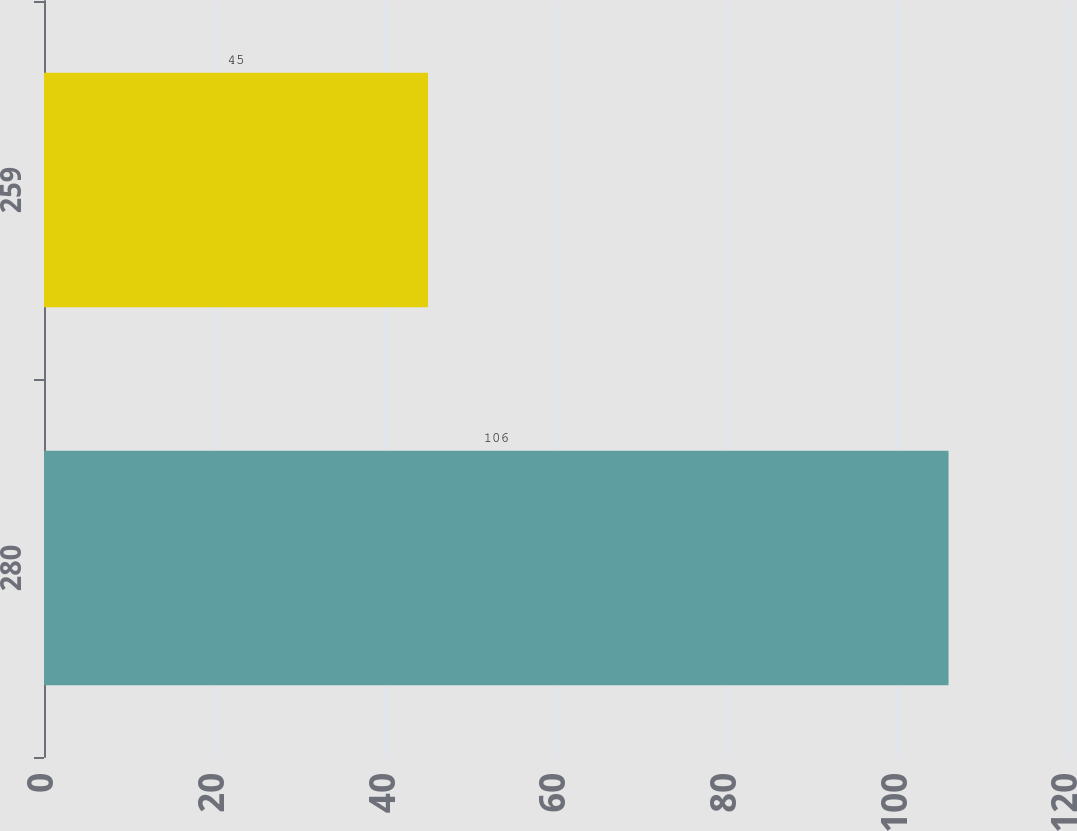Convert chart to OTSL. <chart><loc_0><loc_0><loc_500><loc_500><bar_chart><fcel>280<fcel>259<nl><fcel>106<fcel>45<nl></chart> 